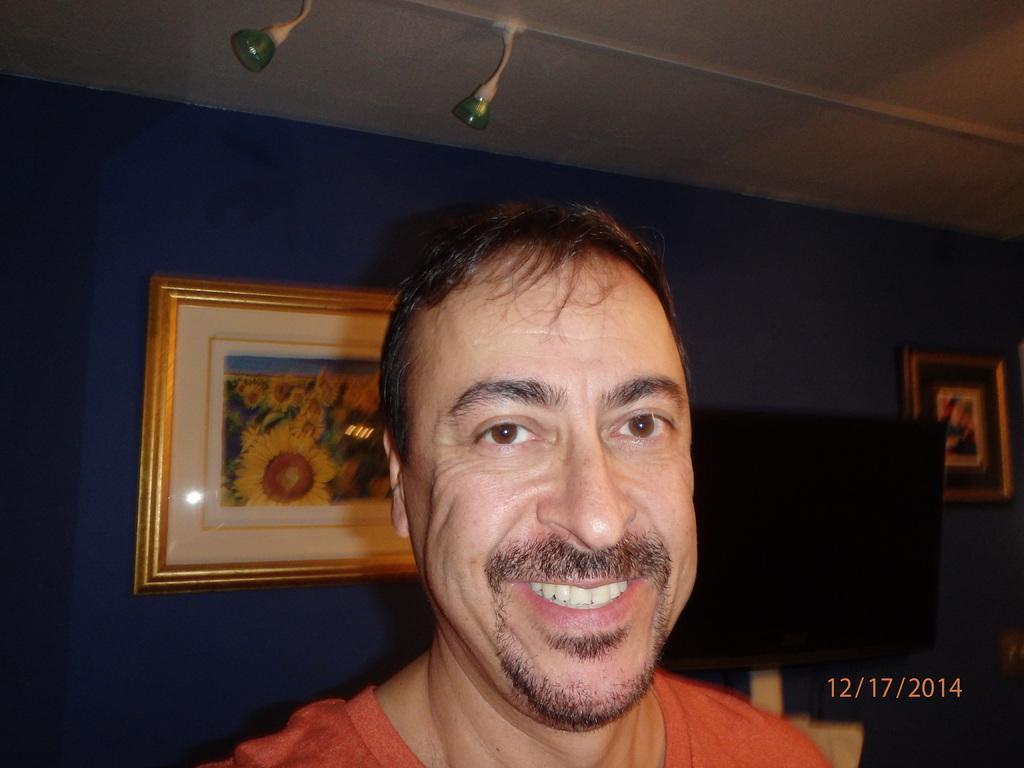Can you describe this image briefly? In this image I can see a person standing and posing for the picture. I can see two wall hangings, at the top of the image I can see two lights I can see a monitor behind the person, In the right bottom corner I can see the date. 